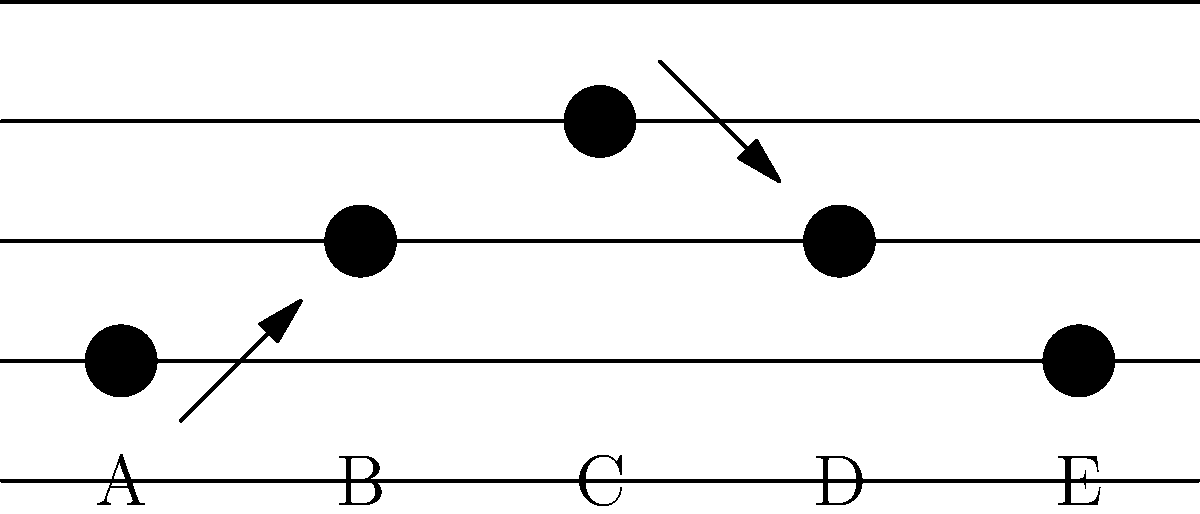As a music producer collaborating with Bette Midler, you need to mentally rotate and align musical notes on a staff to create a harmonious melody. Given the musical staff above with notes labeled A through E, which two notes should be rotated to create a symmetrical pattern that would likely result in a more harmonious melody? To solve this problem, we need to analyze the current pattern of notes and identify which rotations would create symmetry:

1. Note A is on the bottom line of the staff.
2. Note B is on the second line from the bottom.
3. Note C is on the middle line.
4. Note D is on the second line from the bottom (same as B).
5. Note E is on the bottom line (same as A).

To create a symmetrical pattern:

1. The central note (C) should remain in its current position as it serves as the axis of symmetry.
2. Notes B and D are already symmetrical around C.
3. Notes A and E are on the same line, but to create perfect symmetry, one of them needs to be rotated.

The most harmonious and symmetrical arrangement would be achieved by:

4. Rotating note A up to the top line of the staff (mirroring note E's position relative to C).
5. Alternatively, we could rotate note E up to the top line (mirroring note A's position relative to C).

Either of these rotations would create a symmetrical arc-like pattern (low-high-middle-high-low), which is often found in harmonious melodies.
Answer: A and E (rotate either one to the top line) 